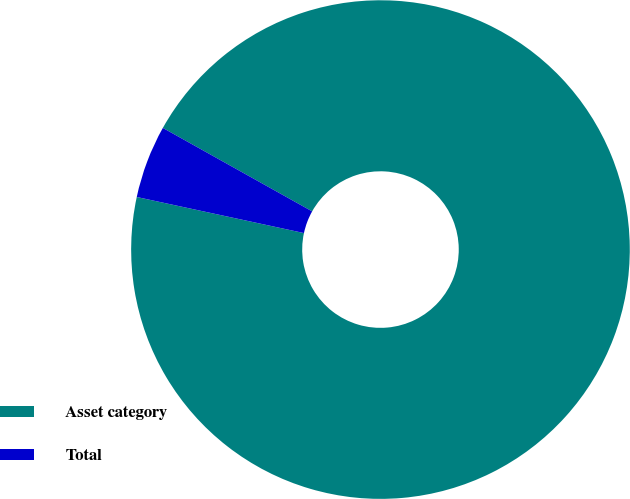<chart> <loc_0><loc_0><loc_500><loc_500><pie_chart><fcel>Asset category<fcel>Total<nl><fcel>95.27%<fcel>4.73%<nl></chart> 